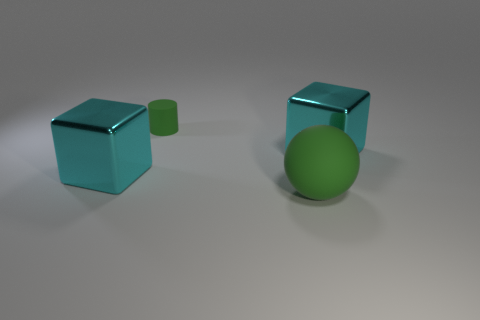Do the cube on the right side of the green cylinder and the small green object have the same size?
Make the answer very short. No. How many rubber objects are green spheres or small green cylinders?
Provide a short and direct response. 2. What number of big metal things are right of the green thing to the right of the small green rubber thing?
Offer a terse response. 1. There is a thing that is to the left of the big green matte thing and in front of the tiny rubber cylinder; what shape is it?
Provide a succinct answer. Cube. What material is the large cyan cube that is on the left side of the green rubber object behind the green thing in front of the tiny thing?
Offer a terse response. Metal. The matte thing that is the same color as the rubber ball is what size?
Provide a succinct answer. Small. What material is the small green cylinder?
Make the answer very short. Rubber. Is the material of the green ball the same as the cyan block to the left of the large green object?
Provide a short and direct response. No. What color is the large object that is in front of the large cyan shiny object on the left side of the small green rubber cylinder?
Keep it short and to the point. Green. What size is the thing that is in front of the tiny green matte object and left of the large rubber ball?
Provide a short and direct response. Large. 